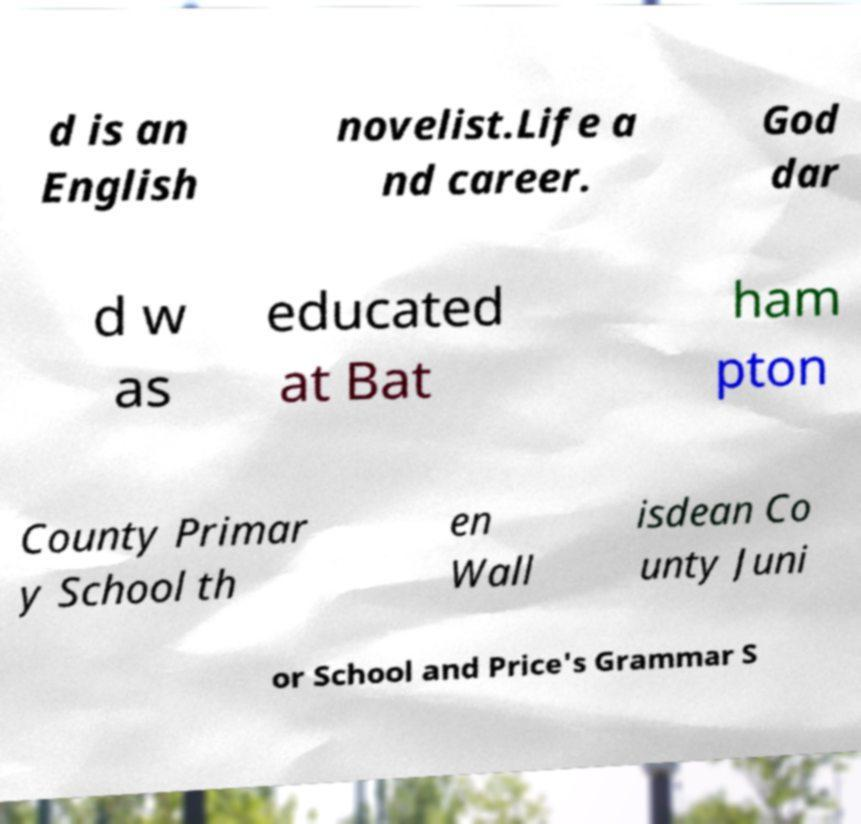What messages or text are displayed in this image? I need them in a readable, typed format. d is an English novelist.Life a nd career. God dar d w as educated at Bat ham pton County Primar y School th en Wall isdean Co unty Juni or School and Price's Grammar S 